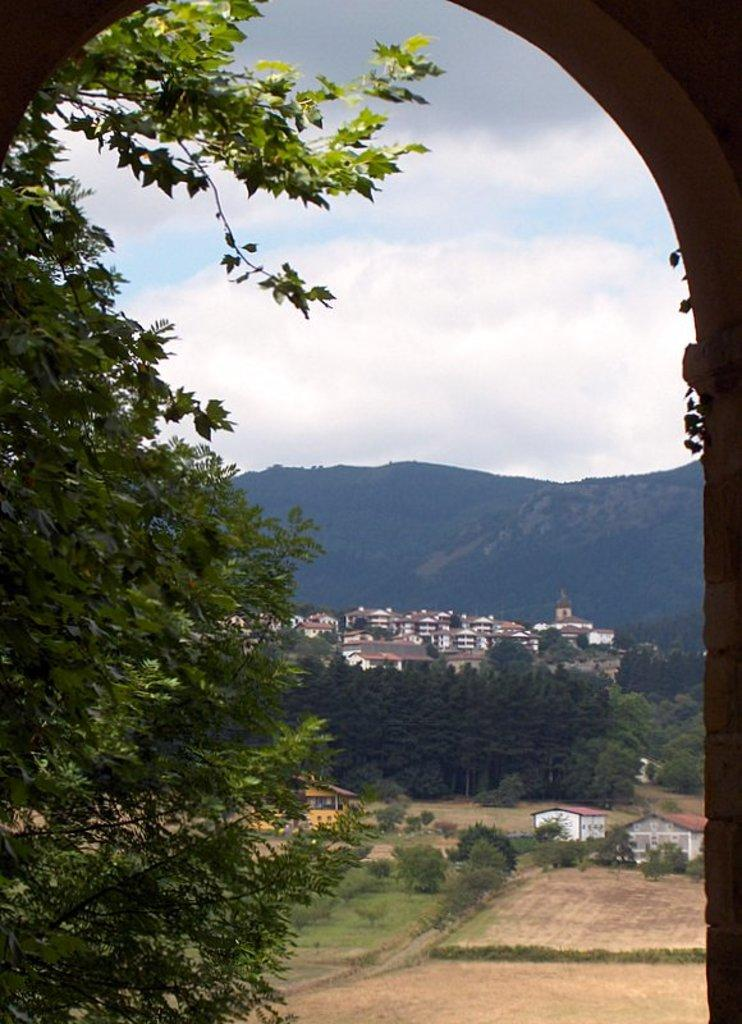What type of natural elements can be seen in the image? There are trees in the image. What type of man-made structures are visible in the image? There are buildings in the image. What type of geographical feature can be seen in the image? There are mountains in the image. What is visible in the sky in the image? The sky is visible in the image, and it has a white and blue color. Can you see a crown on top of the mountains in the image? There is no crown present in the image; it features trees, buildings, mountains, and a sky with a white and blue color. What type of drum can be heard playing in the background of the image? There is no drum present in the image, nor is there any sound mentioned. 